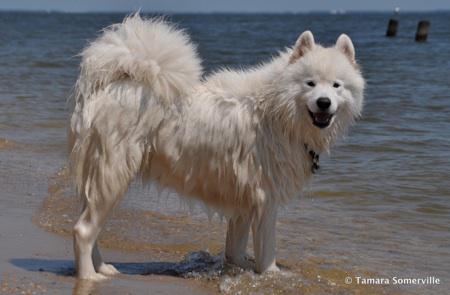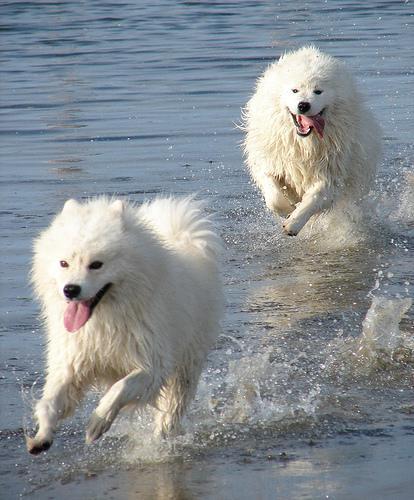The first image is the image on the left, the second image is the image on the right. Examine the images to the left and right. Is the description "There is a dog swimming to the right in both images." accurate? Answer yes or no. No. 